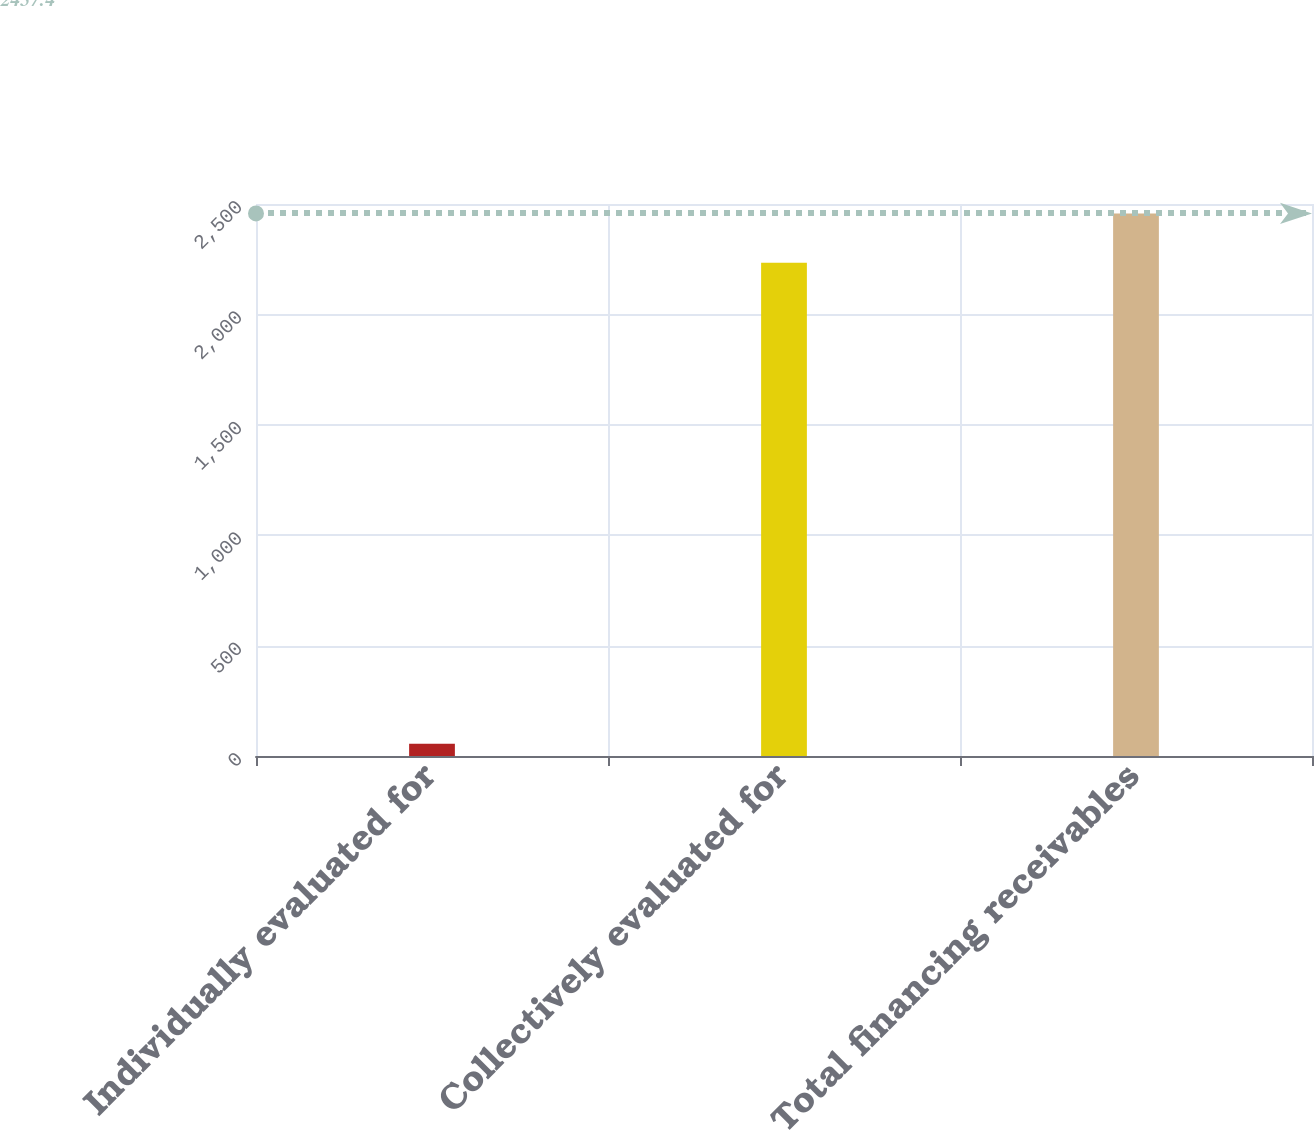Convert chart to OTSL. <chart><loc_0><loc_0><loc_500><loc_500><bar_chart><fcel>Individually evaluated for<fcel>Collectively evaluated for<fcel>Total financing receivables<nl><fcel>55<fcel>2234<fcel>2457.4<nl></chart> 